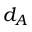Convert formula to latex. <formula><loc_0><loc_0><loc_500><loc_500>d _ { A }</formula> 